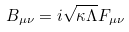<formula> <loc_0><loc_0><loc_500><loc_500>B _ { \mu \nu } = i \sqrt { \kappa \Lambda } F _ { \mu \nu }</formula> 